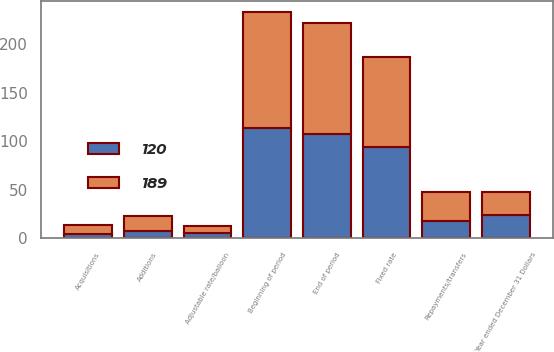<chart> <loc_0><loc_0><loc_500><loc_500><stacked_bar_chart><ecel><fcel>Year ended December 31 Dollars<fcel>Beginning of period<fcel>Acquisitions<fcel>Additions<fcel>Repayments/transfers<fcel>End of period<fcel>Fixed rate<fcel>Adjustable rate/balloon<nl><fcel>120<fcel>24<fcel>114<fcel>4<fcel>8<fcel>18<fcel>108<fcel>94<fcel>6<nl><fcel>189<fcel>24<fcel>119<fcel>10<fcel>15<fcel>30<fcel>114<fcel>93<fcel>7<nl></chart> 